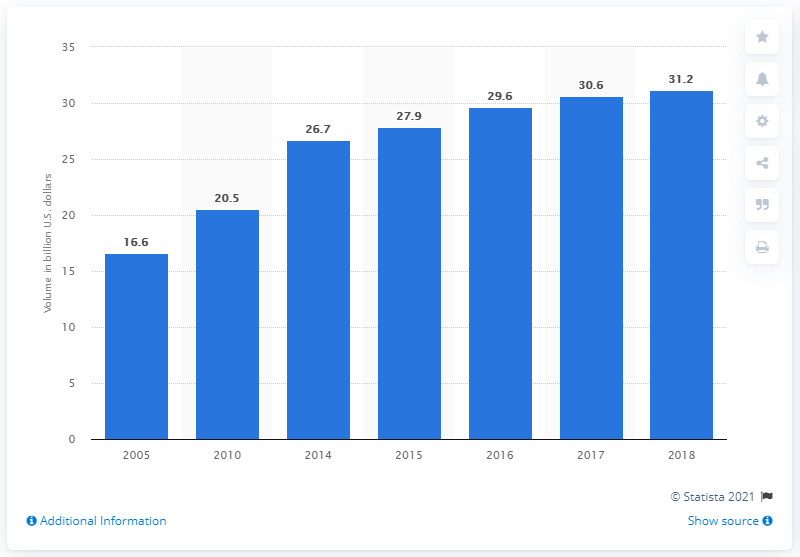Mention a couple of crucial points in this snapshot. In 2018, the average daily trading volume of the corporate debt market in the United States was 31.2 trillion dollars. 